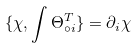<formula> <loc_0><loc_0><loc_500><loc_500>\{ \chi , \int \Theta ^ { T } _ { \circ i } \} = \partial _ { i } \chi</formula> 